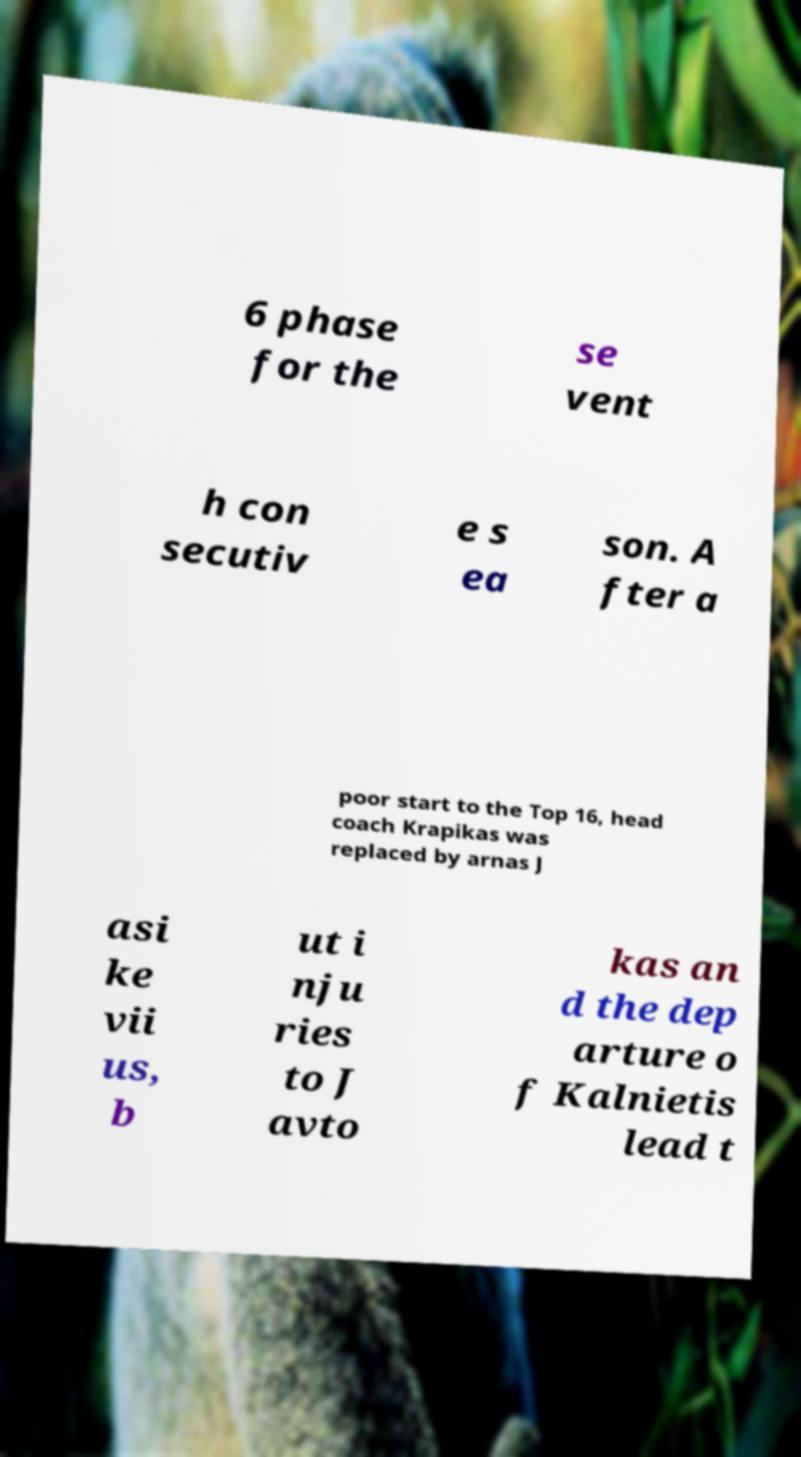There's text embedded in this image that I need extracted. Can you transcribe it verbatim? 6 phase for the se vent h con secutiv e s ea son. A fter a poor start to the Top 16, head coach Krapikas was replaced by arnas J asi ke vii us, b ut i nju ries to J avto kas an d the dep arture o f Kalnietis lead t 